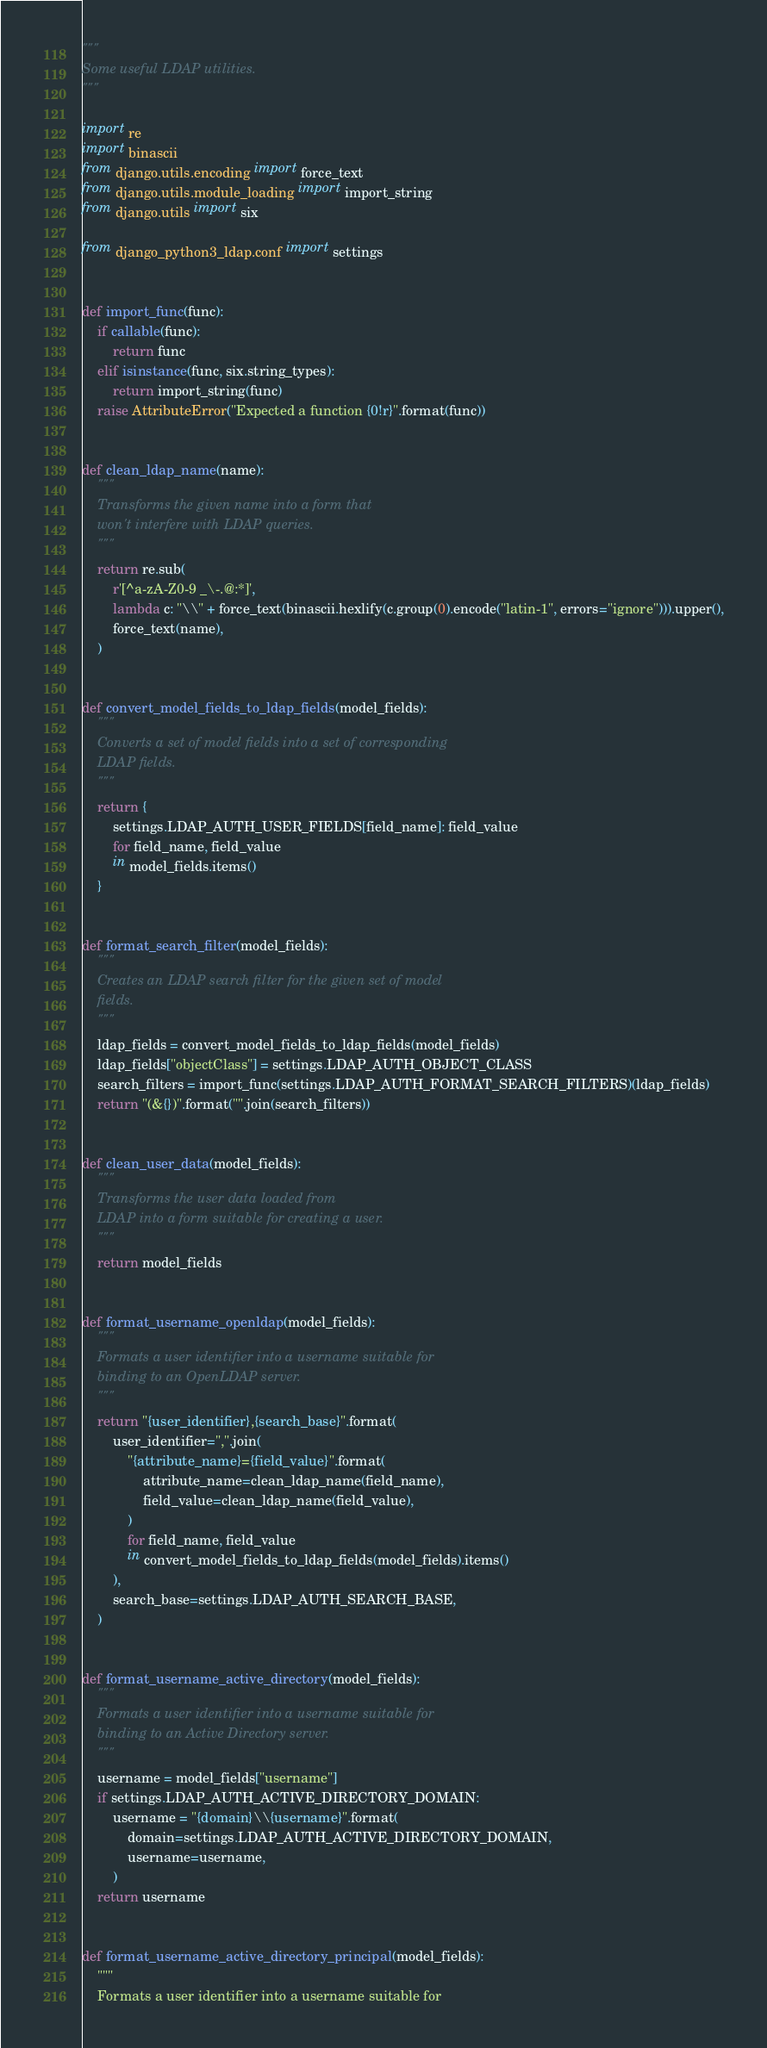Convert code to text. <code><loc_0><loc_0><loc_500><loc_500><_Python_>"""
Some useful LDAP utilities.
"""

import re
import binascii
from django.utils.encoding import force_text
from django.utils.module_loading import import_string
from django.utils import six

from django_python3_ldap.conf import settings


def import_func(func):
    if callable(func):
        return func
    elif isinstance(func, six.string_types):
        return import_string(func)
    raise AttributeError("Expected a function {0!r}".format(func))


def clean_ldap_name(name):
    """
    Transforms the given name into a form that
    won't interfere with LDAP queries.
    """
    return re.sub(
        r'[^a-zA-Z0-9 _\-.@:*]',
        lambda c: "\\" + force_text(binascii.hexlify(c.group(0).encode("latin-1", errors="ignore"))).upper(),
        force_text(name),
    )


def convert_model_fields_to_ldap_fields(model_fields):
    """
    Converts a set of model fields into a set of corresponding
    LDAP fields.
    """
    return {
        settings.LDAP_AUTH_USER_FIELDS[field_name]: field_value
        for field_name, field_value
        in model_fields.items()
    }


def format_search_filter(model_fields):
    """
    Creates an LDAP search filter for the given set of model
    fields.
    """
    ldap_fields = convert_model_fields_to_ldap_fields(model_fields)
    ldap_fields["objectClass"] = settings.LDAP_AUTH_OBJECT_CLASS
    search_filters = import_func(settings.LDAP_AUTH_FORMAT_SEARCH_FILTERS)(ldap_fields)
    return "(&{})".format("".join(search_filters))


def clean_user_data(model_fields):
    """
    Transforms the user data loaded from
    LDAP into a form suitable for creating a user.
    """
    return model_fields


def format_username_openldap(model_fields):
    """
    Formats a user identifier into a username suitable for
    binding to an OpenLDAP server.
    """
    return "{user_identifier},{search_base}".format(
        user_identifier=",".join(
            "{attribute_name}={field_value}".format(
                attribute_name=clean_ldap_name(field_name),
                field_value=clean_ldap_name(field_value),
            )
            for field_name, field_value
            in convert_model_fields_to_ldap_fields(model_fields).items()
        ),
        search_base=settings.LDAP_AUTH_SEARCH_BASE,
    )


def format_username_active_directory(model_fields):
    """
    Formats a user identifier into a username suitable for
    binding to an Active Directory server.
    """
    username = model_fields["username"]
    if settings.LDAP_AUTH_ACTIVE_DIRECTORY_DOMAIN:
        username = "{domain}\\{username}".format(
            domain=settings.LDAP_AUTH_ACTIVE_DIRECTORY_DOMAIN,
            username=username,
        )
    return username


def format_username_active_directory_principal(model_fields):
    """
    Formats a user identifier into a username suitable for</code> 